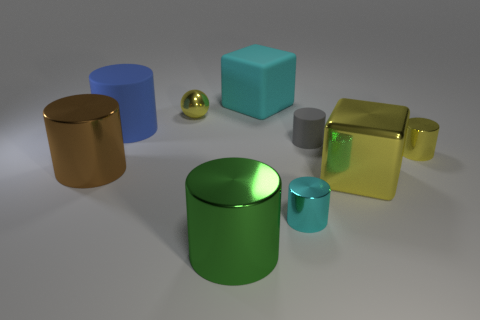Subtract all green cylinders. How many cylinders are left? 5 Subtract all small yellow metal cylinders. How many cylinders are left? 5 Subtract all blue cylinders. Subtract all brown balls. How many cylinders are left? 5 Add 1 yellow cubes. How many objects exist? 10 Subtract all spheres. How many objects are left? 8 Subtract all tiny yellow metallic cylinders. Subtract all metallic cylinders. How many objects are left? 4 Add 4 tiny spheres. How many tiny spheres are left? 5 Add 8 big purple rubber cubes. How many big purple rubber cubes exist? 8 Subtract 1 brown cylinders. How many objects are left? 8 